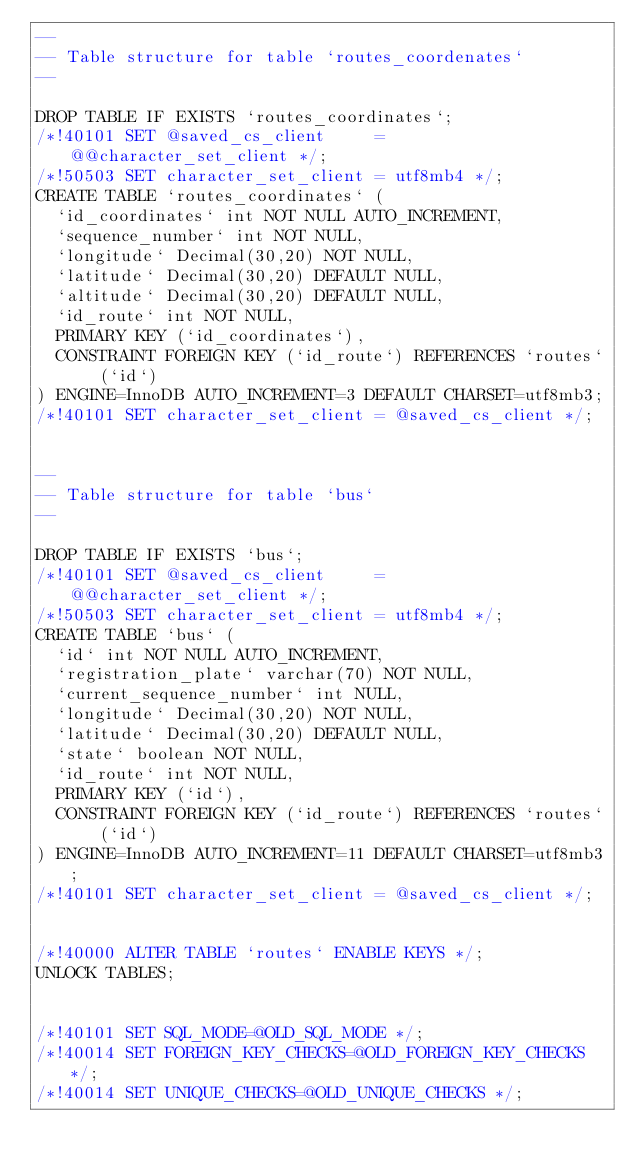Convert code to text. <code><loc_0><loc_0><loc_500><loc_500><_SQL_>--
-- Table structure for table `routes_coordenates`
--

DROP TABLE IF EXISTS `routes_coordinates`;
/*!40101 SET @saved_cs_client     = @@character_set_client */;
/*!50503 SET character_set_client = utf8mb4 */;
CREATE TABLE `routes_coordinates` (
  `id_coordinates` int NOT NULL AUTO_INCREMENT,
  `sequence_number` int NOT NULL,
  `longitude` Decimal(30,20) NOT NULL,
  `latitude` Decimal(30,20) DEFAULT NULL,
  `altitude` Decimal(30,20) DEFAULT NULL,
  `id_route` int NOT NULL,
  PRIMARY KEY (`id_coordinates`),
  CONSTRAINT FOREIGN KEY (`id_route`) REFERENCES `routes` (`id`)
) ENGINE=InnoDB AUTO_INCREMENT=3 DEFAULT CHARSET=utf8mb3;
/*!40101 SET character_set_client = @saved_cs_client */;


--
-- Table structure for table `bus`
--

DROP TABLE IF EXISTS `bus`;
/*!40101 SET @saved_cs_client     = @@character_set_client */;
/*!50503 SET character_set_client = utf8mb4 */;
CREATE TABLE `bus` (
  `id` int NOT NULL AUTO_INCREMENT,
  `registration_plate` varchar(70) NOT NULL,
  `current_sequence_number` int NULL,
  `longitude` Decimal(30,20) NOT NULL,
  `latitude` Decimal(30,20) DEFAULT NULL,
  `state` boolean NOT NULL,
  `id_route` int NOT NULL,
  PRIMARY KEY (`id`),
  CONSTRAINT FOREIGN KEY (`id_route`) REFERENCES `routes` (`id`)
) ENGINE=InnoDB AUTO_INCREMENT=11 DEFAULT CHARSET=utf8mb3;
/*!40101 SET character_set_client = @saved_cs_client */;


/*!40000 ALTER TABLE `routes` ENABLE KEYS */;
UNLOCK TABLES;


/*!40101 SET SQL_MODE=@OLD_SQL_MODE */;
/*!40014 SET FOREIGN_KEY_CHECKS=@OLD_FOREIGN_KEY_CHECKS */;
/*!40014 SET UNIQUE_CHECKS=@OLD_UNIQUE_CHECKS */;</code> 